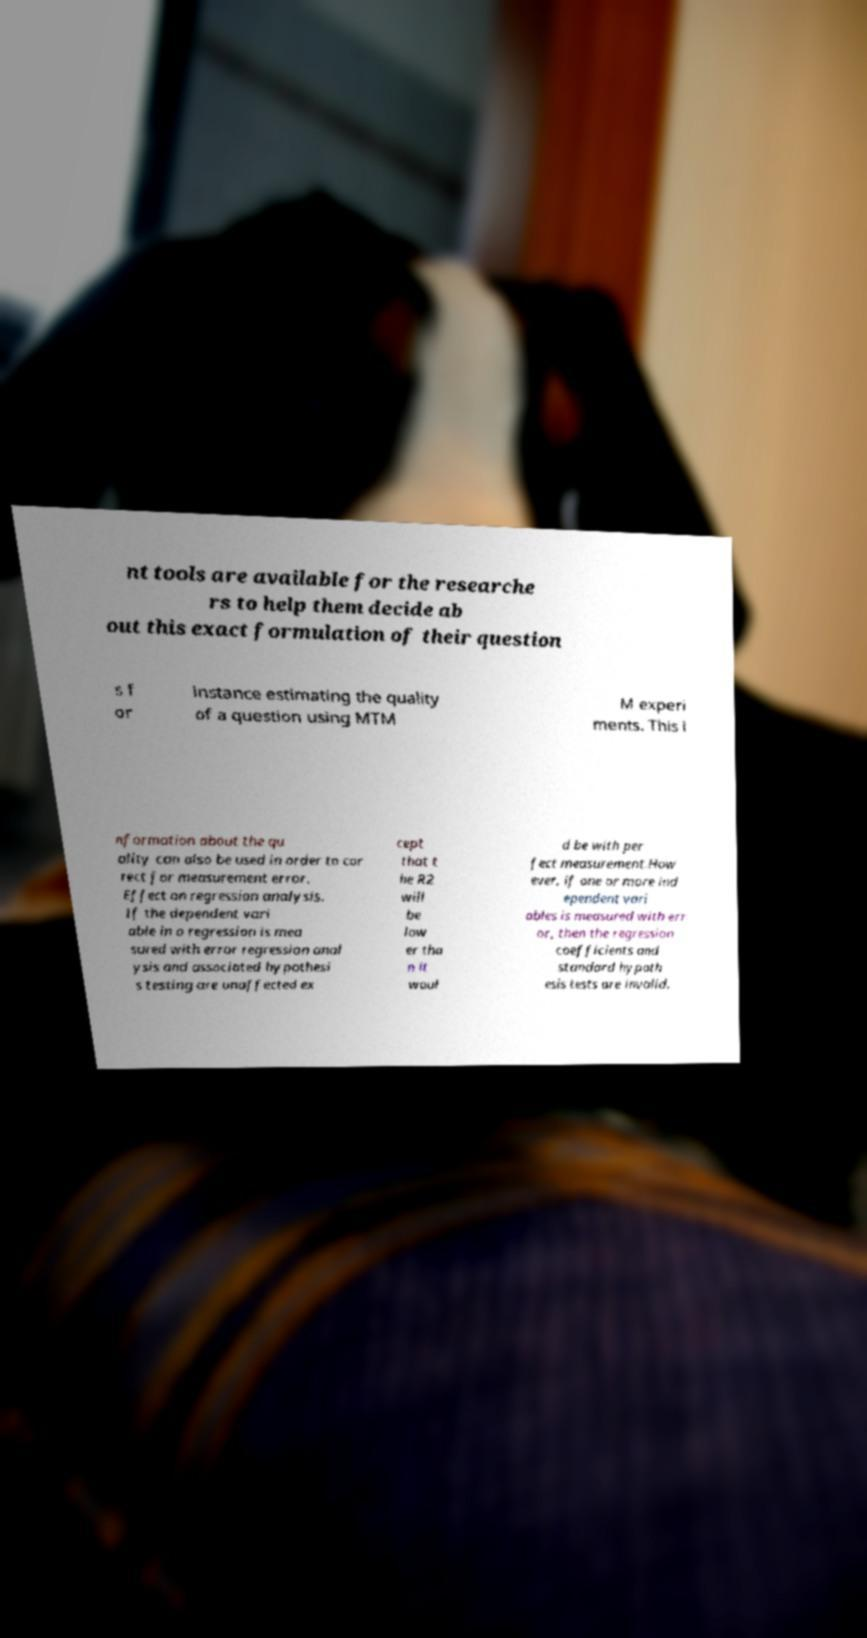I need the written content from this picture converted into text. Can you do that? nt tools are available for the researche rs to help them decide ab out this exact formulation of their question s f or instance estimating the quality of a question using MTM M experi ments. This i nformation about the qu ality can also be used in order to cor rect for measurement error. Effect on regression analysis. If the dependent vari able in a regression is mea sured with error regression anal ysis and associated hypothesi s testing are unaffected ex cept that t he R2 will be low er tha n it woul d be with per fect measurement.How ever, if one or more ind ependent vari ables is measured with err or, then the regression coefficients and standard hypoth esis tests are invalid. 